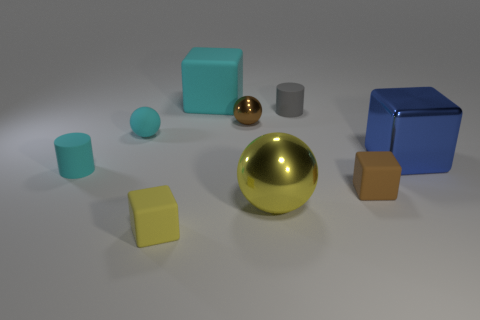Subtract all metallic balls. How many balls are left? 1 Subtract all blue cubes. How many cubes are left? 3 Add 1 brown rubber cubes. How many objects exist? 10 Subtract all red blocks. Subtract all yellow balls. How many blocks are left? 4 Subtract all balls. How many objects are left? 6 Subtract all gray things. Subtract all big yellow shiny spheres. How many objects are left? 7 Add 5 large metal spheres. How many large metal spheres are left? 6 Add 7 small blue shiny blocks. How many small blue shiny blocks exist? 7 Subtract 1 blue cubes. How many objects are left? 8 